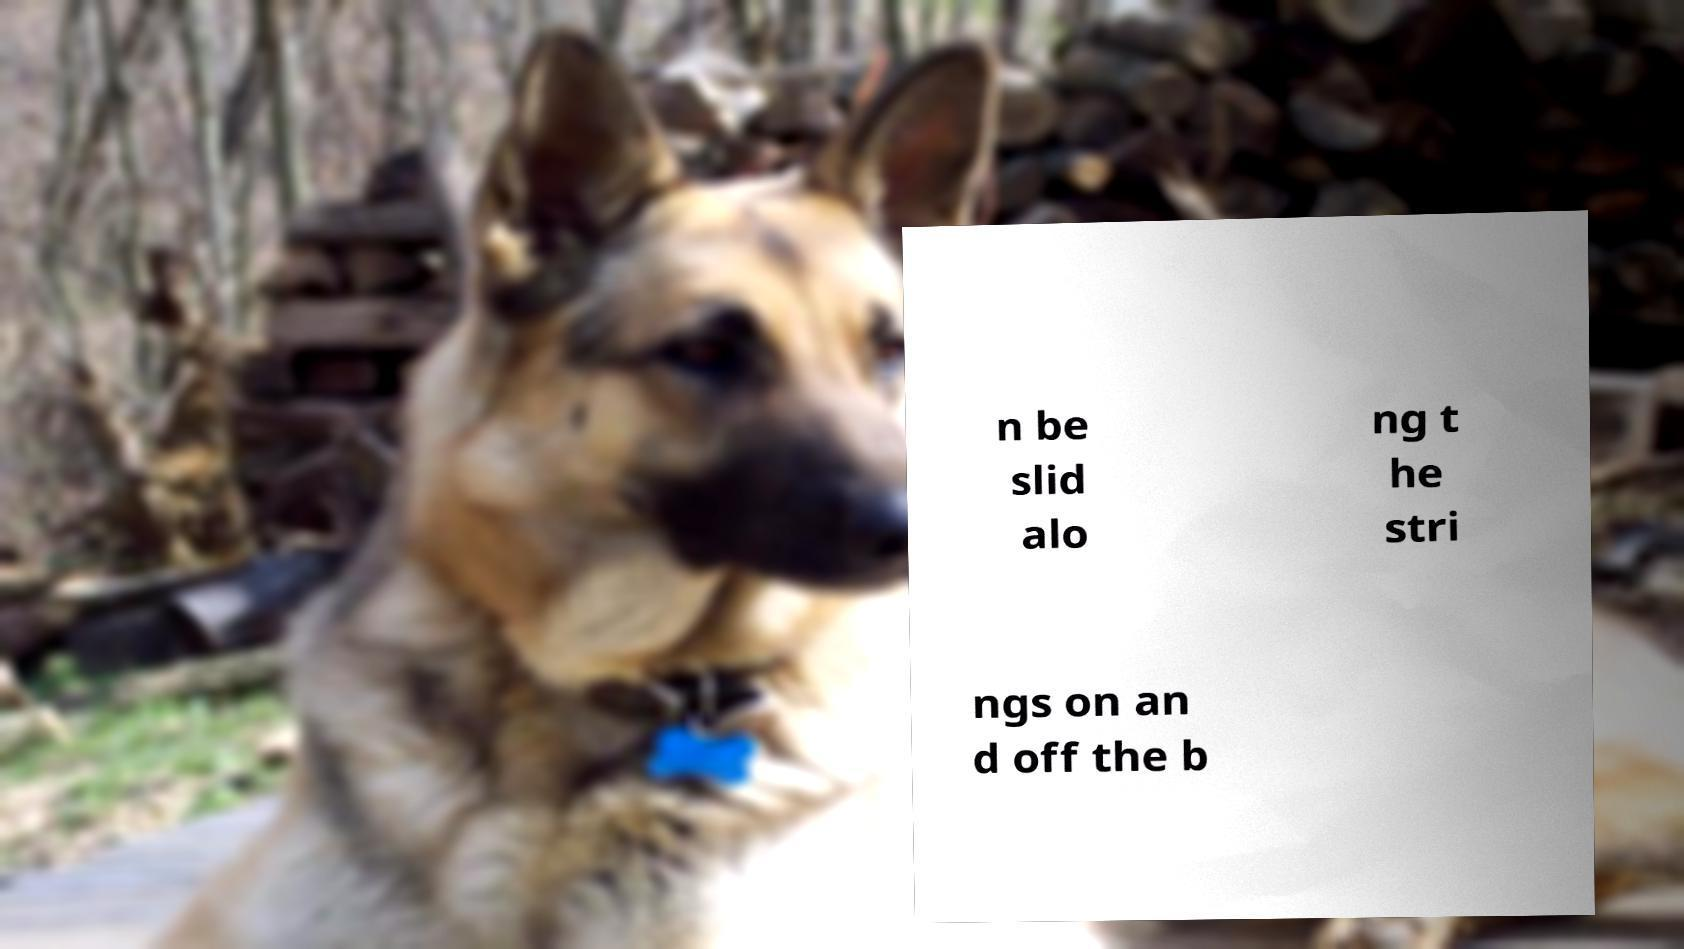For documentation purposes, I need the text within this image transcribed. Could you provide that? n be slid alo ng t he stri ngs on an d off the b 